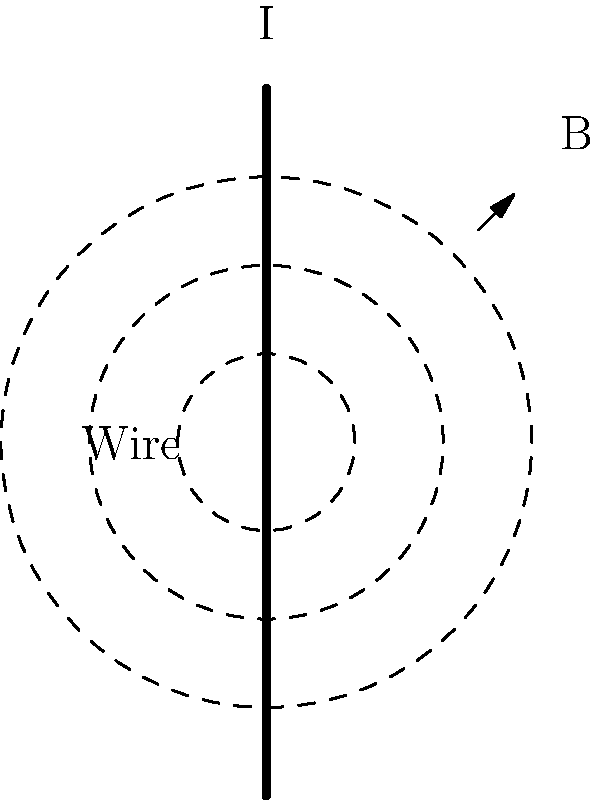Your aunt, a property appraiser with a background in electrical engineering, shows you a diagram of a straight wire carrying a current $I$. She explains that the magnetic field $B$ around the wire forms concentric circles. If the magnetic field strength at a distance $r$ from the wire is given by the equation $B = \frac{\mu_0 I}{2\pi r}$, where $\mu_0$ is the permeability of free space, how would the magnetic field strength change if you doubled the distance from the wire? Let's approach this step-by-step:

1) The equation for the magnetic field strength is:

   $B = \frac{\mu_0 I}{2\pi r}$

2) Let's call the initial distance $r_1$ and the initial magnetic field strength $B_1$. So:

   $B_1 = \frac{\mu_0 I}{2\pi r_1}$

3) Now, we double the distance. The new distance is $r_2 = 2r_1$. Let's call the new magnetic field strength $B_2$:

   $B_2 = \frac{\mu_0 I}{2\pi r_2} = \frac{\mu_0 I}{2\pi (2r_1)}$

4) We can simplify this:

   $B_2 = \frac{\mu_0 I}{4\pi r_1}$

5) Now, let's compare $B_2$ to $B_1$:

   $B_2 = \frac{\mu_0 I}{4\pi r_1} = \frac{1}{2} \cdot \frac{\mu_0 I}{2\pi r_1} = \frac{1}{2} B_1$

6) This means that when we double the distance, the magnetic field strength becomes half of its original value.
Answer: The magnetic field strength would halve. 